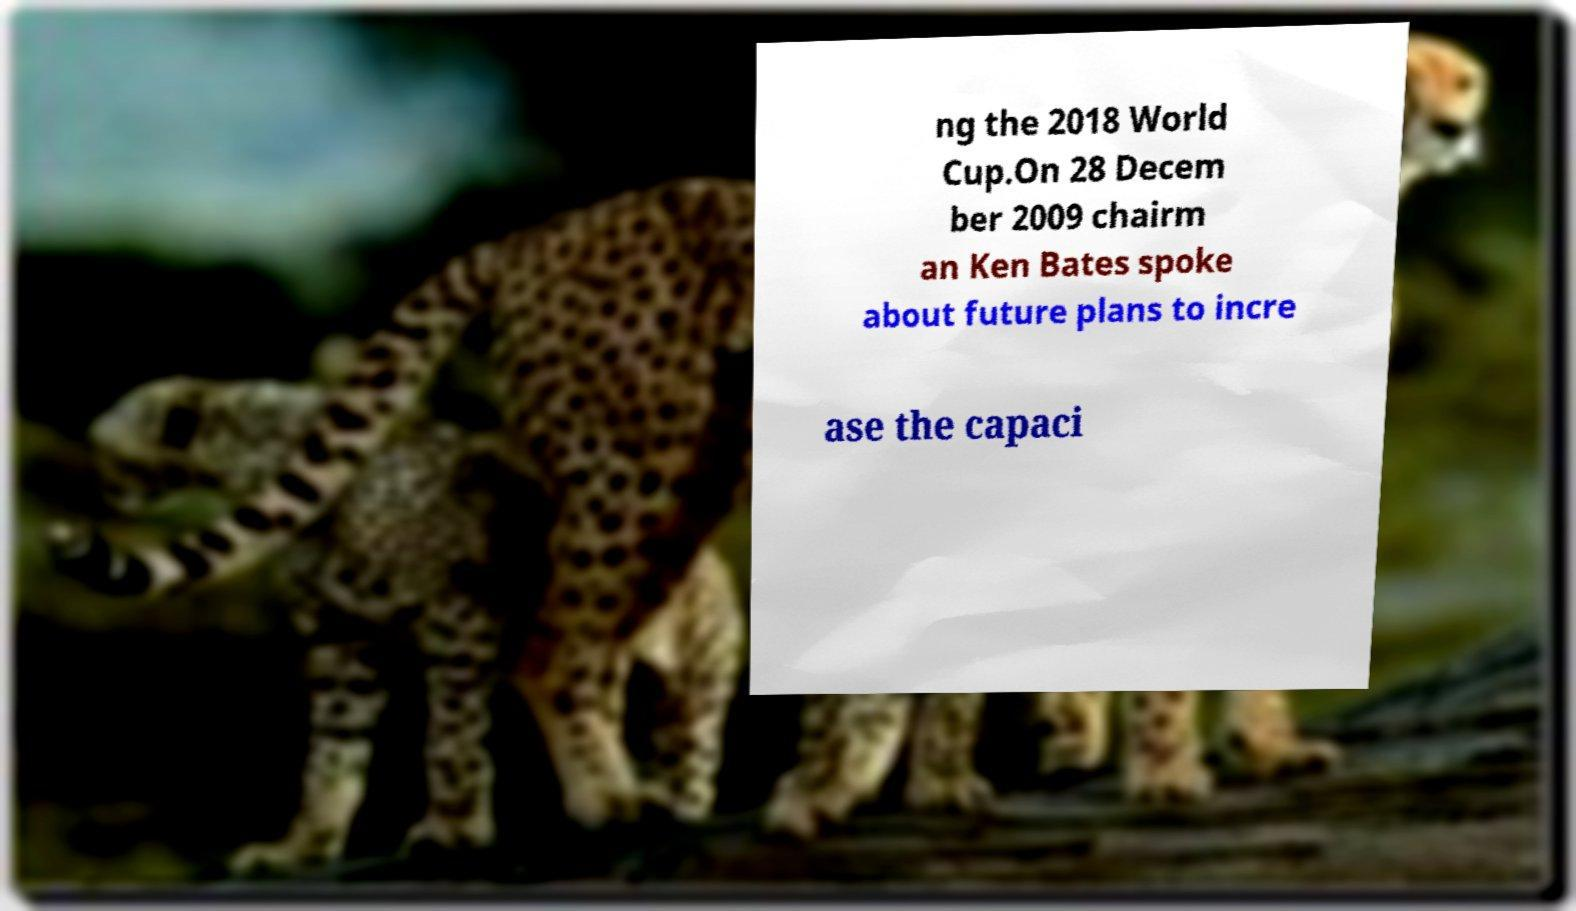Can you accurately transcribe the text from the provided image for me? ng the 2018 World Cup.On 28 Decem ber 2009 chairm an Ken Bates spoke about future plans to incre ase the capaci 